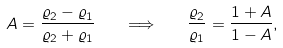Convert formula to latex. <formula><loc_0><loc_0><loc_500><loc_500>A = \frac { \varrho _ { 2 } - \varrho _ { 1 } } { \varrho _ { 2 } + \varrho _ { 1 } } \quad \Longrightarrow \quad \frac { \varrho _ { 2 } } { \varrho _ { 1 } } = \frac { 1 + A } { 1 - A } ,</formula> 